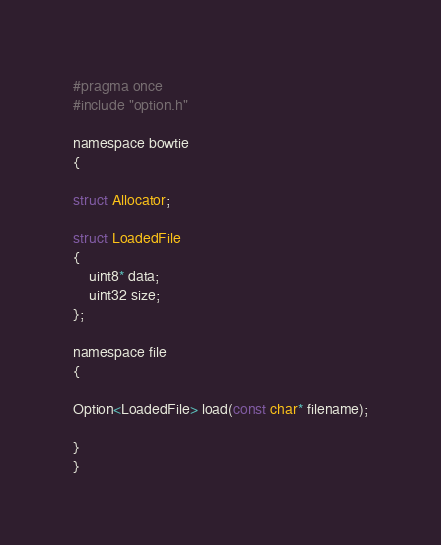<code> <loc_0><loc_0><loc_500><loc_500><_C_>#pragma once
#include "option.h"

namespace bowtie
{

struct Allocator;

struct LoadedFile
{
    uint8* data;
    uint32 size;
};

namespace file
{

Option<LoadedFile> load(const char* filename);

}
}</code> 